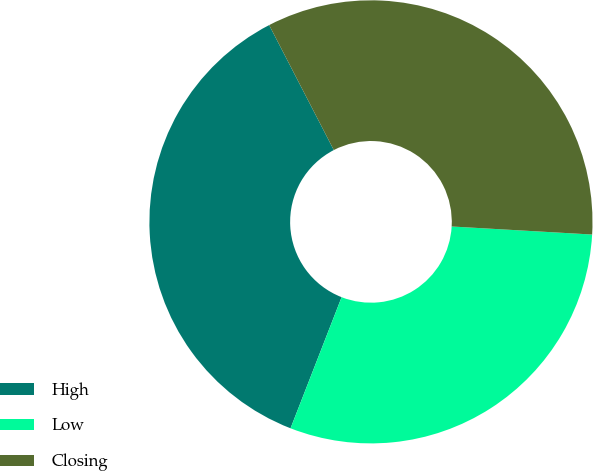Convert chart. <chart><loc_0><loc_0><loc_500><loc_500><pie_chart><fcel>High<fcel>Low<fcel>Closing<nl><fcel>36.49%<fcel>30.0%<fcel>33.51%<nl></chart> 